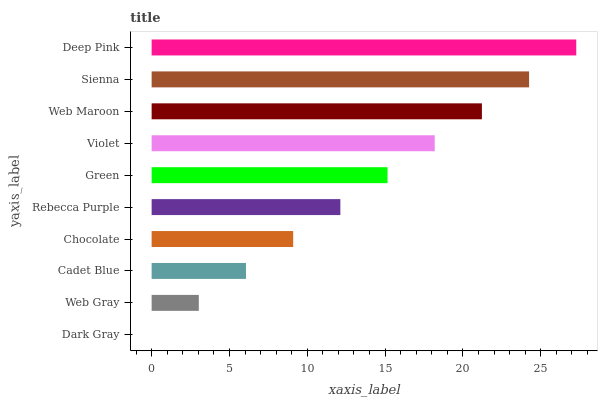Is Dark Gray the minimum?
Answer yes or no. Yes. Is Deep Pink the maximum?
Answer yes or no. Yes. Is Web Gray the minimum?
Answer yes or no. No. Is Web Gray the maximum?
Answer yes or no. No. Is Web Gray greater than Dark Gray?
Answer yes or no. Yes. Is Dark Gray less than Web Gray?
Answer yes or no. Yes. Is Dark Gray greater than Web Gray?
Answer yes or no. No. Is Web Gray less than Dark Gray?
Answer yes or no. No. Is Green the high median?
Answer yes or no. Yes. Is Rebecca Purple the low median?
Answer yes or no. Yes. Is Cadet Blue the high median?
Answer yes or no. No. Is Web Maroon the low median?
Answer yes or no. No. 